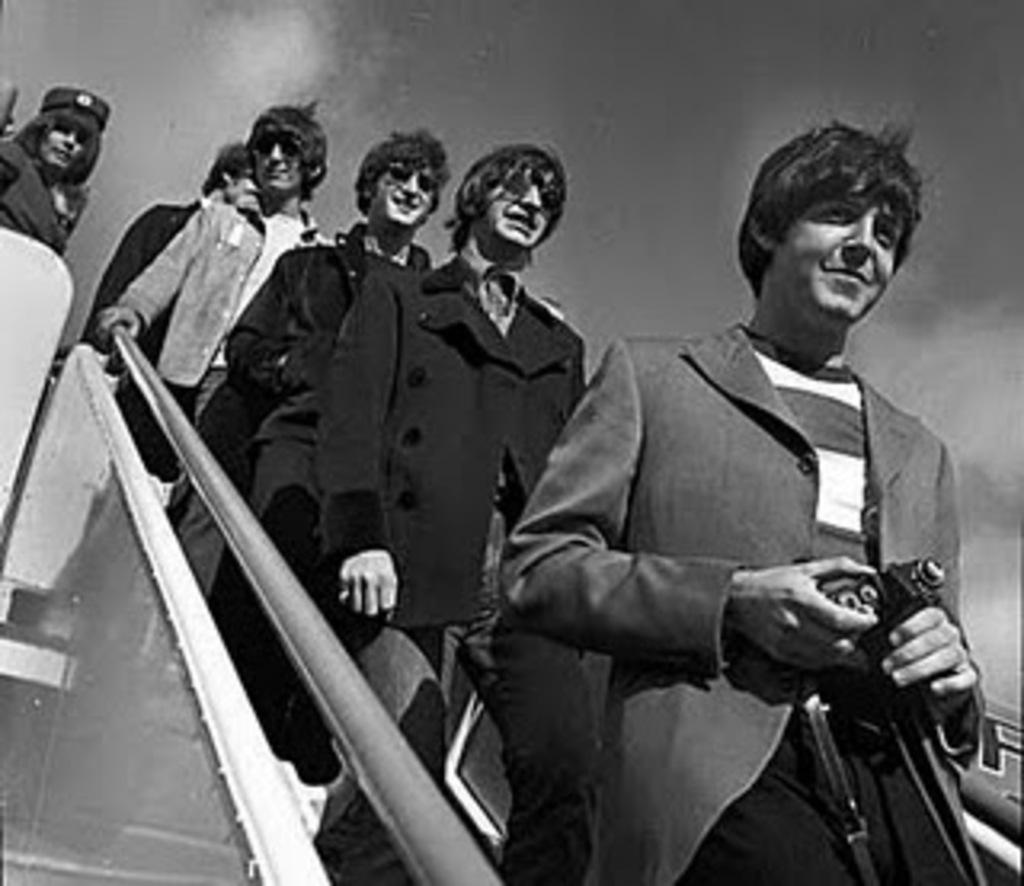What is happening in the image involving a group of people? The group of people are walking on steps in the image. Can you describe the man in the image? The man is holding a camera in the image. How is the man holding the camera? The man is holding the camera with his hands. What can be seen in the background of the image? The sky is visible in the background of the image. What type of vest is the man wearing in the image? There is no vest visible in the image; the man is holding a camera with his hands. What kind of structure can be seen in the background of the image? The background of the image only shows the sky, so no specific structure can be identified. 